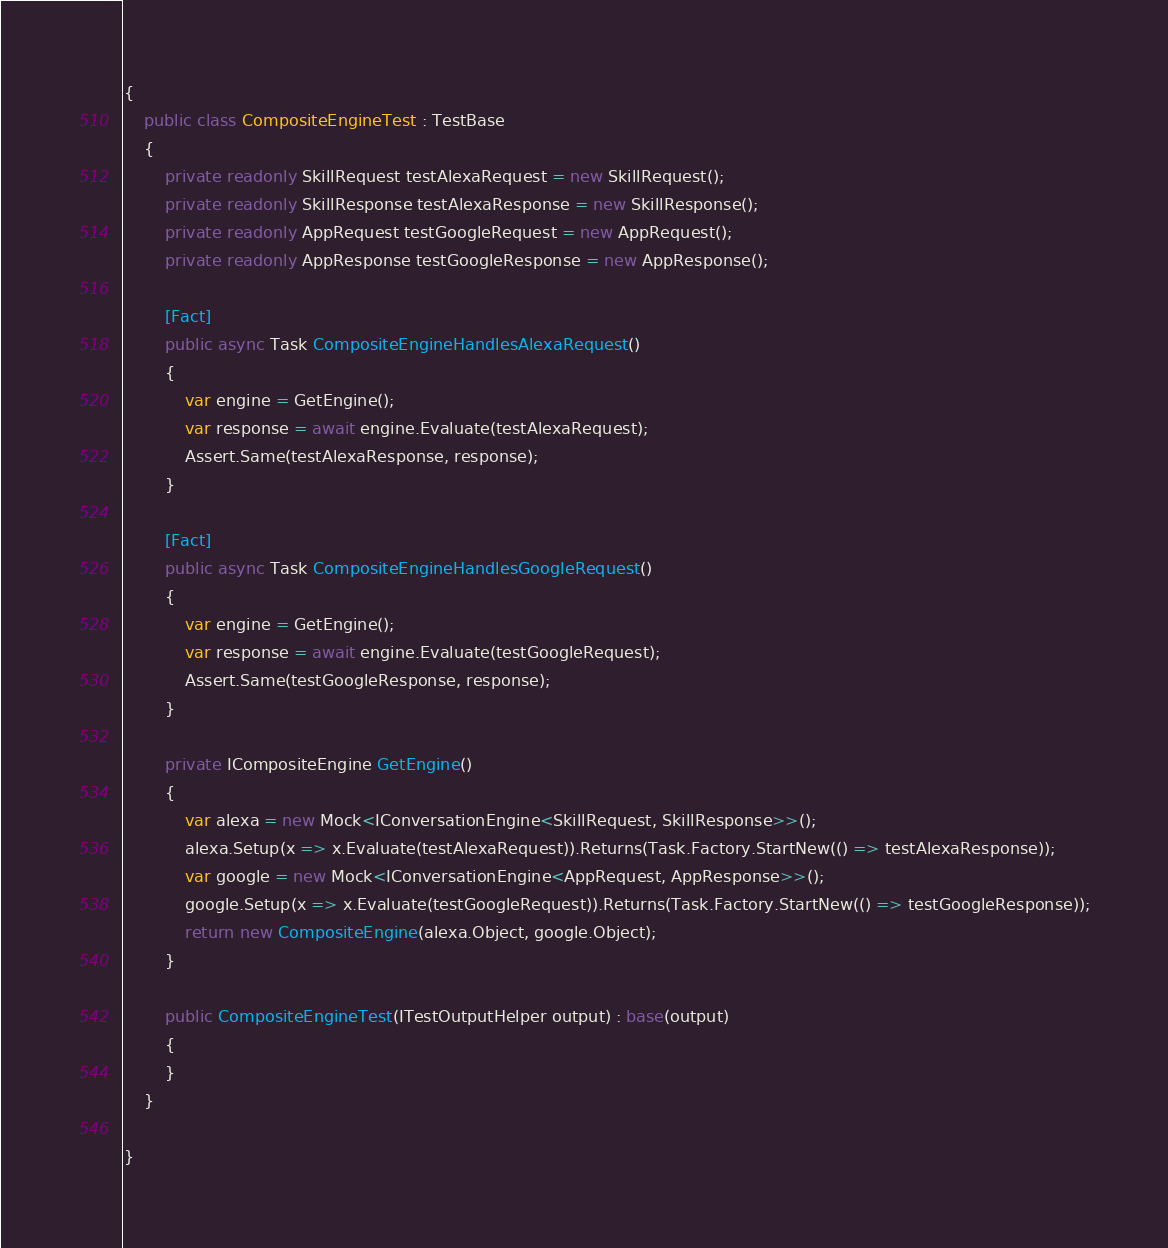Convert code to text. <code><loc_0><loc_0><loc_500><loc_500><_C#_>{
    public class CompositeEngineTest : TestBase
    {
        private readonly SkillRequest testAlexaRequest = new SkillRequest();
        private readonly SkillResponse testAlexaResponse = new SkillResponse();
        private readonly AppRequest testGoogleRequest = new AppRequest();
        private readonly AppResponse testGoogleResponse = new AppResponse();

        [Fact]
        public async Task CompositeEngineHandlesAlexaRequest()
        {
            var engine = GetEngine();
            var response = await engine.Evaluate(testAlexaRequest);
            Assert.Same(testAlexaResponse, response);
        }

        [Fact]
        public async Task CompositeEngineHandlesGoogleRequest()
        {
            var engine = GetEngine();
            var response = await engine.Evaluate(testGoogleRequest);
            Assert.Same(testGoogleResponse, response);
        }
        
        private ICompositeEngine GetEngine()
        {
            var alexa = new Mock<IConversationEngine<SkillRequest, SkillResponse>>();
            alexa.Setup(x => x.Evaluate(testAlexaRequest)).Returns(Task.Factory.StartNew(() => testAlexaResponse));
            var google = new Mock<IConversationEngine<AppRequest, AppResponse>>();
            google.Setup(x => x.Evaluate(testGoogleRequest)).Returns(Task.Factory.StartNew(() => testGoogleResponse));
            return new CompositeEngine(alexa.Object, google.Object);
        }

        public CompositeEngineTest(ITestOutputHelper output) : base(output)
        {
        }
    }

}</code> 